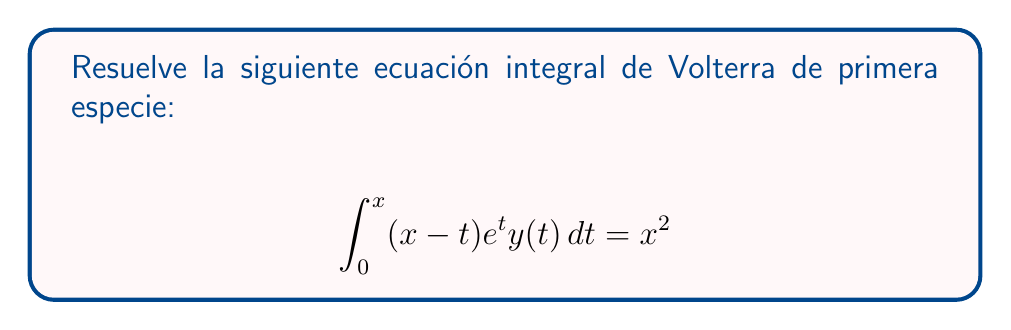Teach me how to tackle this problem. Para resolver esta ecuación integral de Volterra de primera especie, seguiremos estos pasos:

1) Primero, diferenciamos ambos lados de la ecuación con respecto a x:

   $$\frac{d}{dx}\left[\int_0^x (x-t)e^t y(t) dt\right] = \frac{d}{dx}[x^2]$$

2) Aplicando la regla de Leibniz para la diferenciación bajo el signo integral:

   $$\int_0^x e^t y(t) dt + (x-x)e^x y(x) = 2x$$

3) Simplificando:

   $$\int_0^x e^t y(t) dt = 2x$$

4) Ahora tenemos una ecuación integral de Volterra de segunda especie. Diferenciamos nuevamente:

   $$\frac{d}{dx}\left[\int_0^x e^t y(t) dt\right] = \frac{d}{dx}[2x]$$

5) Aplicando nuevamente la regla de Leibniz:

   $$e^x y(x) = 2$$

6) Despejamos y(x):

   $$y(x) = 2e^{-x}$$

7) Verificamos la solución sustituyéndola en la ecuación original:

   $$\int_0^x (x-t)e^t \cdot 2e^{-t} dt = \int_0^x 2(x-t) dt = 2[xt - \frac{t^2}{2}]_0^x = 2(x^2 - \frac{x^2}{2}) = x^2$$

   Lo cual confirma que nuestra solución es correcta.
Answer: $y(x) = 2e^{-x}$ 